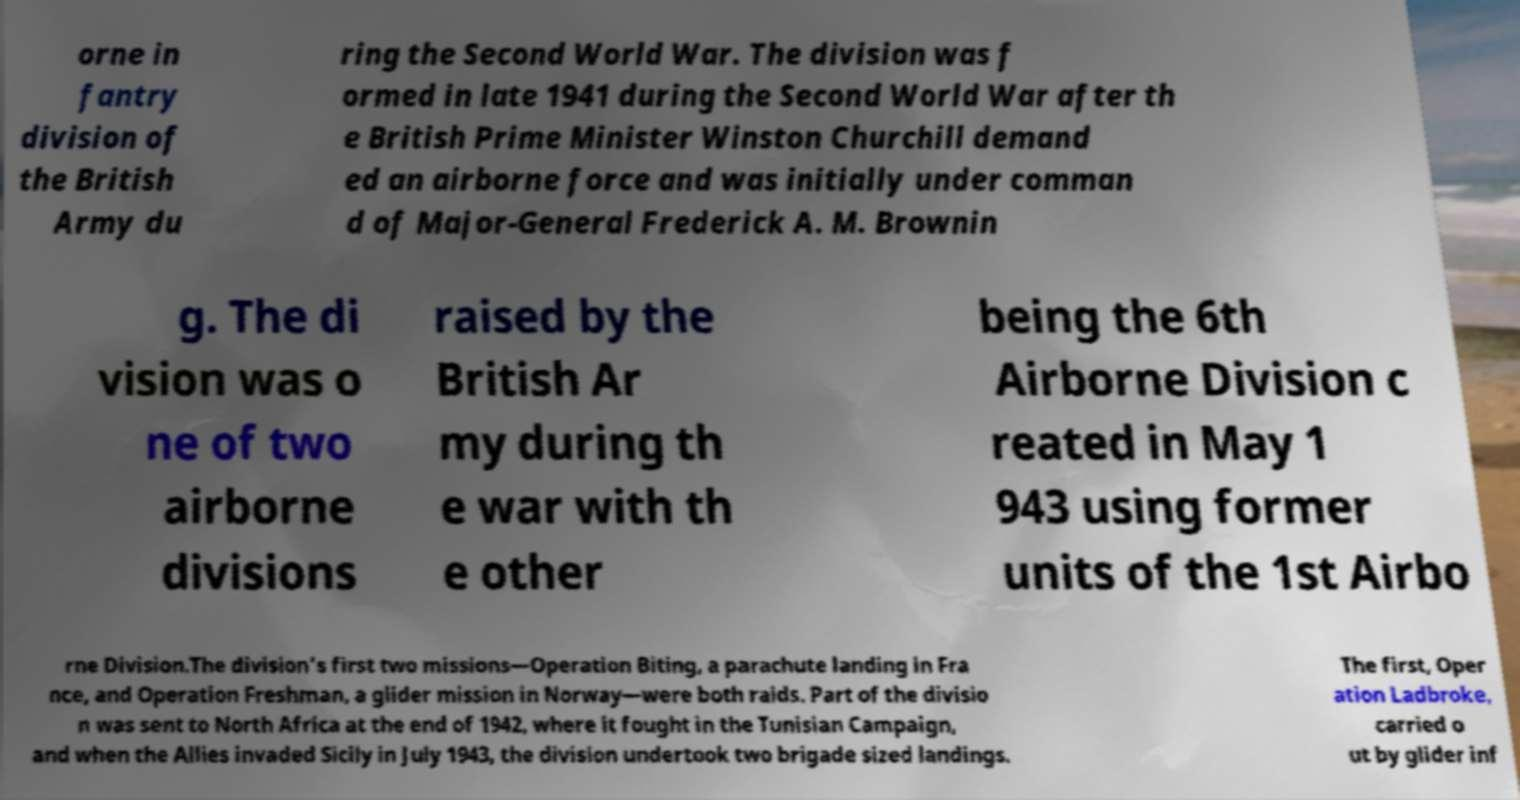Could you assist in decoding the text presented in this image and type it out clearly? orne in fantry division of the British Army du ring the Second World War. The division was f ormed in late 1941 during the Second World War after th e British Prime Minister Winston Churchill demand ed an airborne force and was initially under comman d of Major-General Frederick A. M. Brownin g. The di vision was o ne of two airborne divisions raised by the British Ar my during th e war with th e other being the 6th Airborne Division c reated in May 1 943 using former units of the 1st Airbo rne Division.The division's first two missions—Operation Biting, a parachute landing in Fra nce, and Operation Freshman, a glider mission in Norway—were both raids. Part of the divisio n was sent to North Africa at the end of 1942, where it fought in the Tunisian Campaign, and when the Allies invaded Sicily in July 1943, the division undertook two brigade sized landings. The first, Oper ation Ladbroke, carried o ut by glider inf 